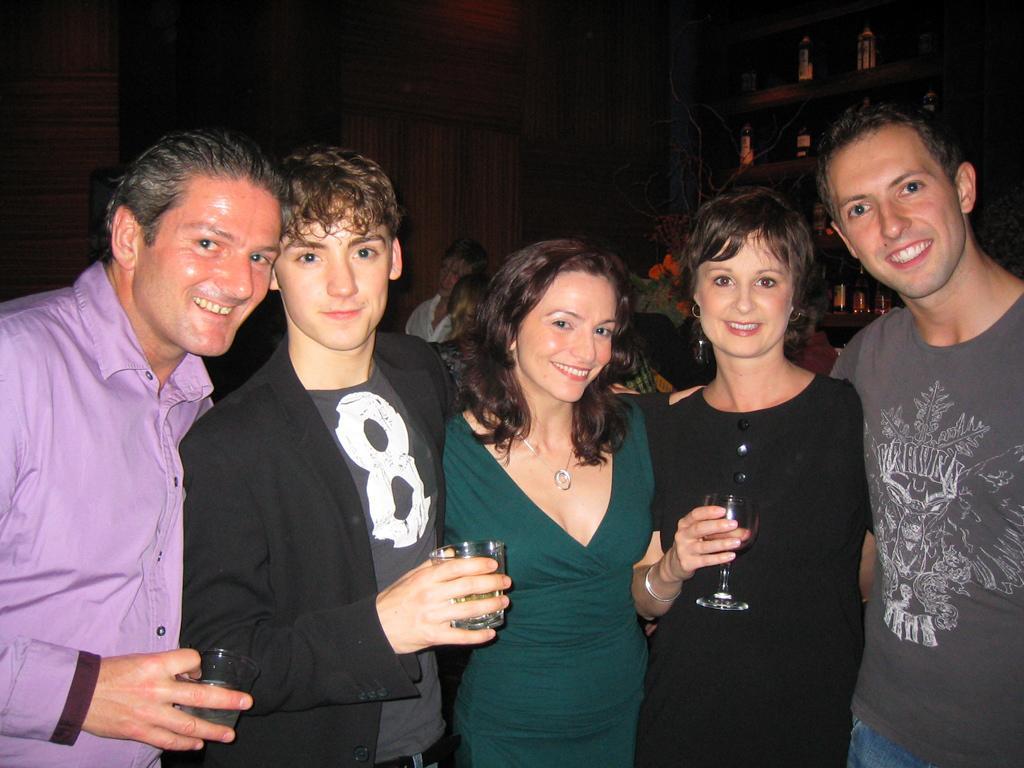Can you describe this image briefly? In this picture there are group of people standing and smiling and holding the glass. At the back there are bottles in the cupboard and there are group of people. 